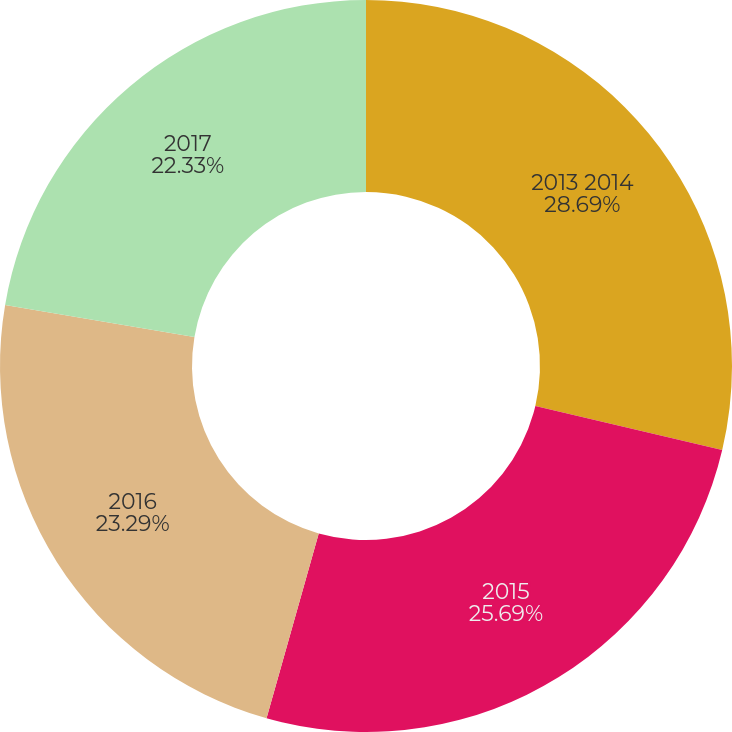<chart> <loc_0><loc_0><loc_500><loc_500><pie_chart><fcel>2013 2014<fcel>2015<fcel>2016<fcel>2017<nl><fcel>28.69%<fcel>25.69%<fcel>23.29%<fcel>22.33%<nl></chart> 